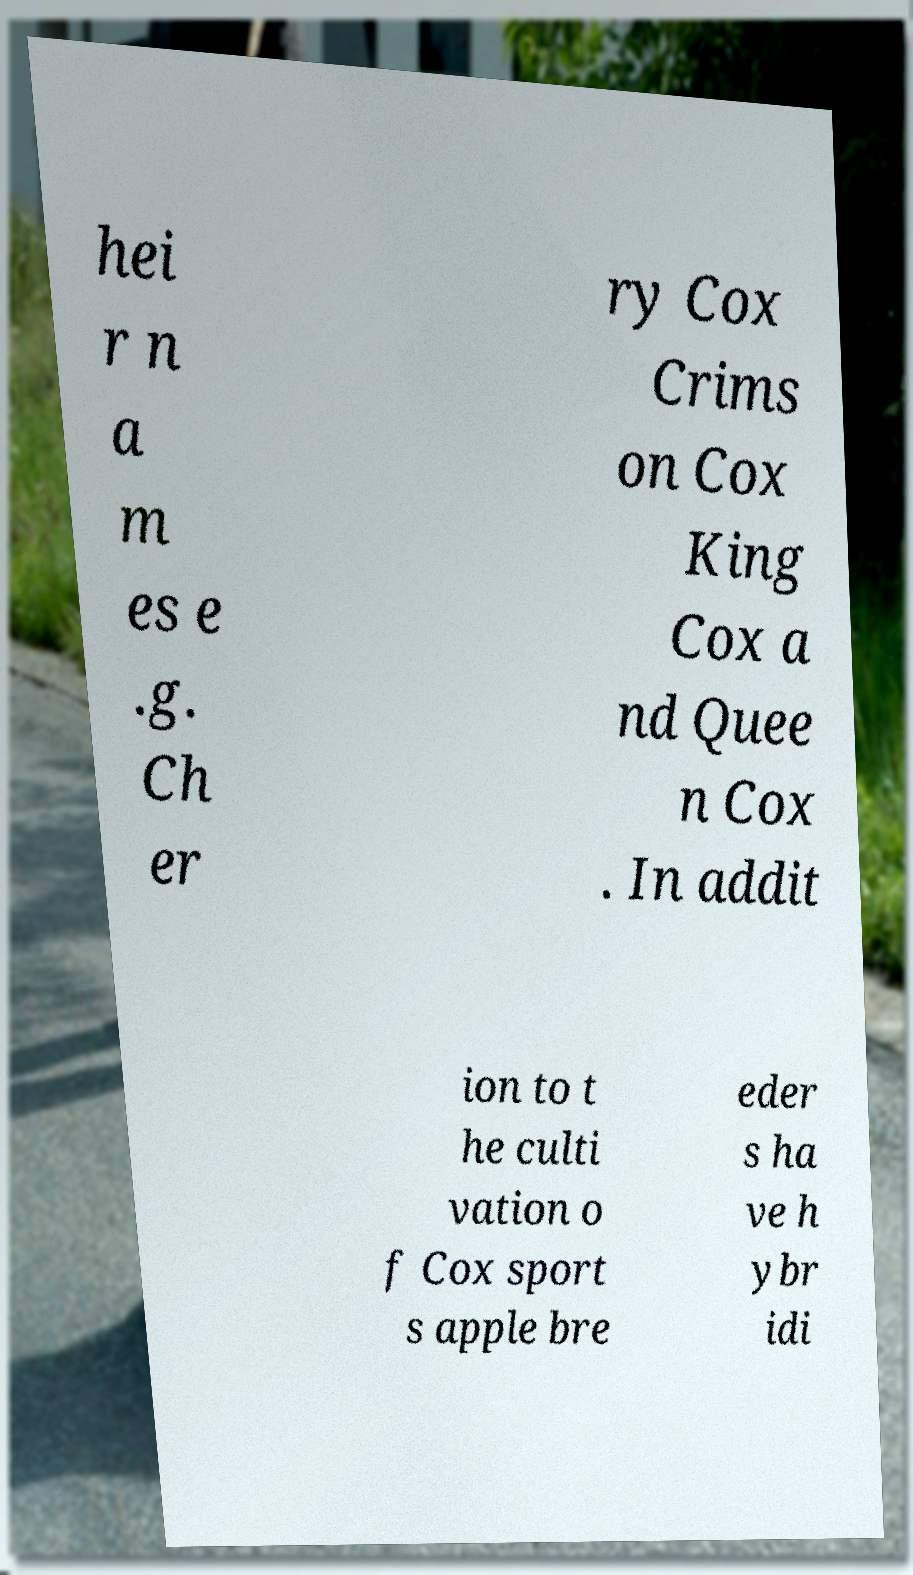Could you extract and type out the text from this image? hei r n a m es e .g. Ch er ry Cox Crims on Cox King Cox a nd Quee n Cox . In addit ion to t he culti vation o f Cox sport s apple bre eder s ha ve h ybr idi 